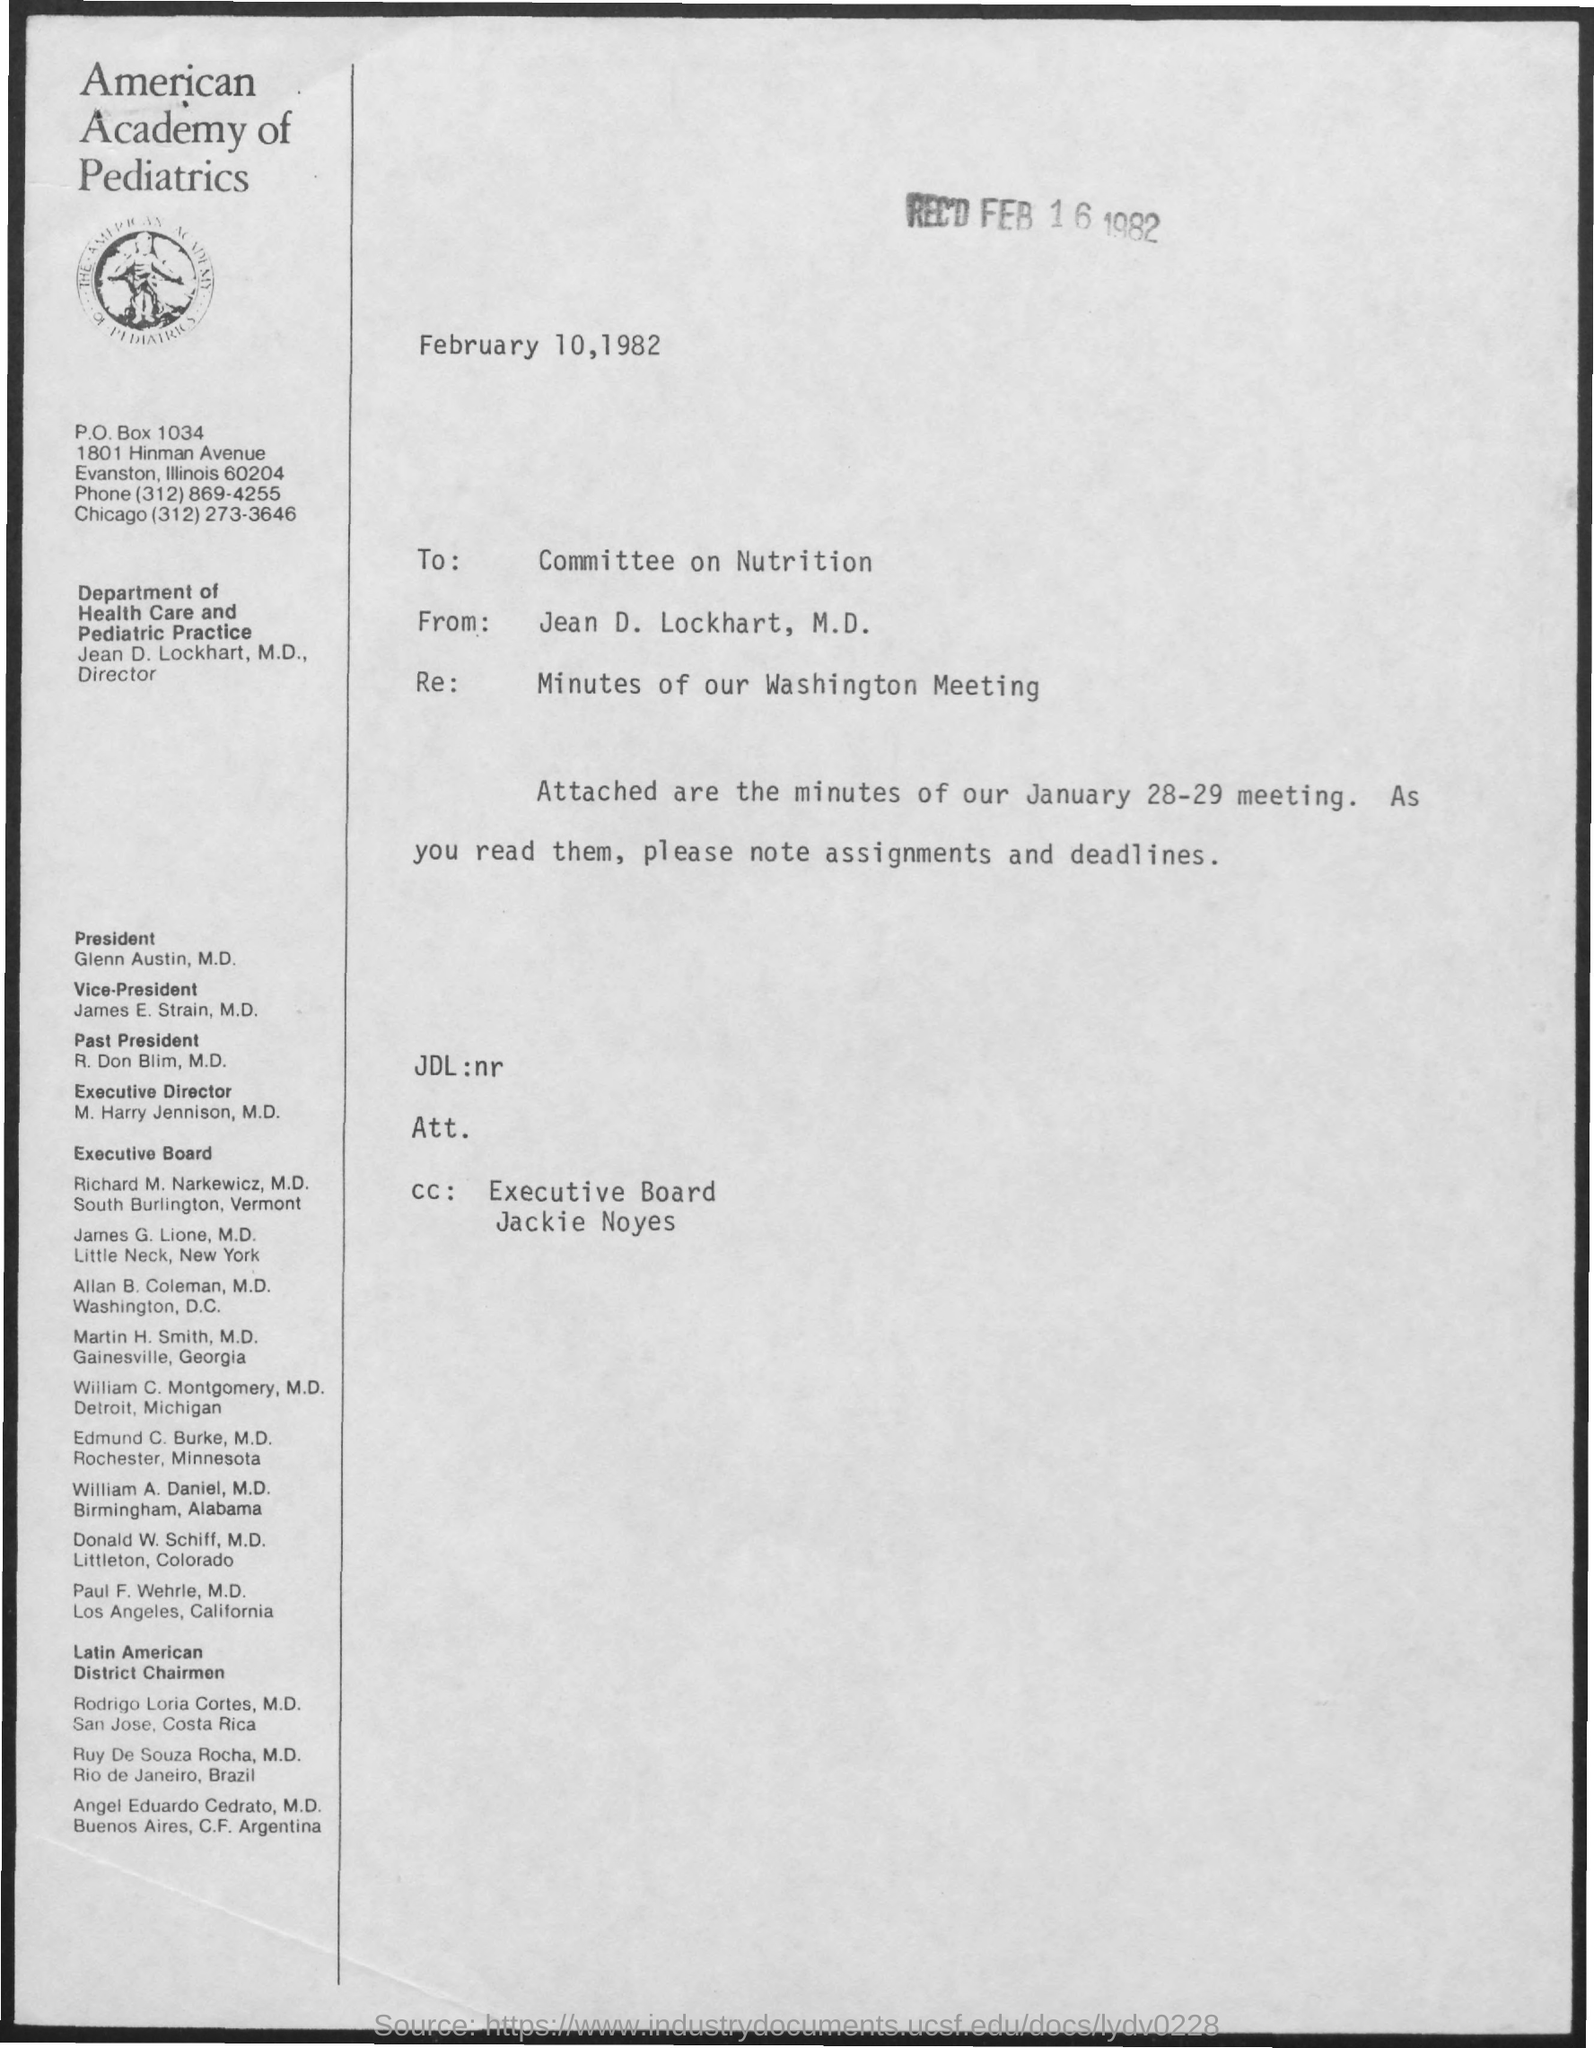When is it received?
Offer a very short reply. FEB 16 1982. To Whom is this letter addressed to?
Your response must be concise. Committee on Nutrition. Who is this letter from?
Make the answer very short. Jean D. Lockhart. What is the Re:?
Your response must be concise. Minutes of our Washington Meeting. 